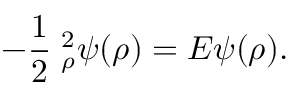Convert formula to latex. <formula><loc_0><loc_0><loc_500><loc_500>- \frac { 1 } { 2 } { \nabla } _ { \rho } ^ { 2 } \psi ( \rho ) = E \psi ( \rho ) .</formula> 